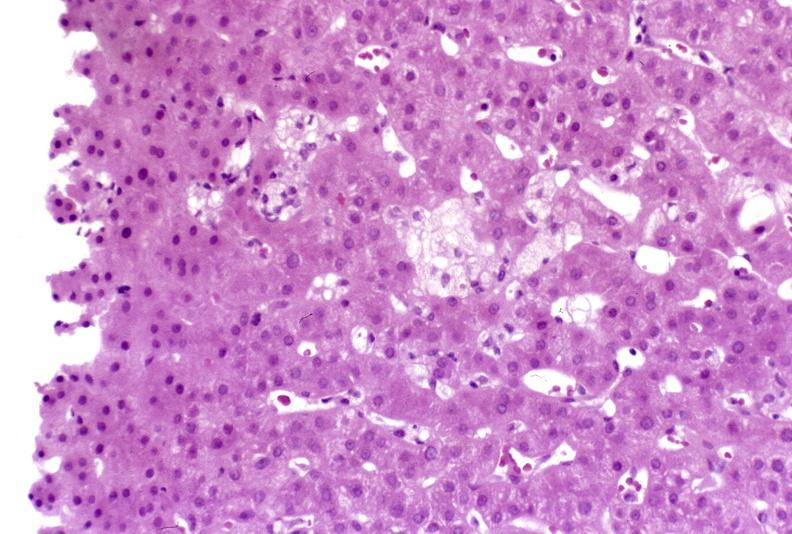s liver present?
Answer the question using a single word or phrase. Yes 